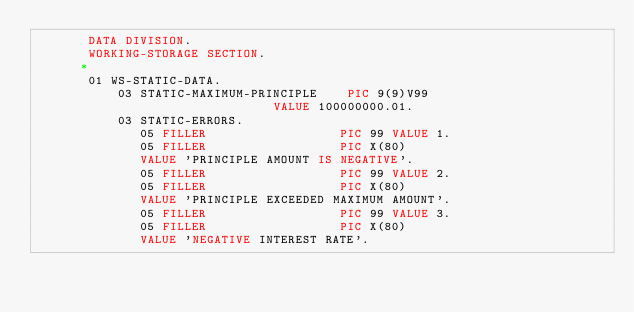<code> <loc_0><loc_0><loc_500><loc_500><_COBOL_>       DATA DIVISION.
       WORKING-STORAGE SECTION.
      *
       01 WS-STATIC-DATA.
           03 STATIC-MAXIMUM-PRINCIPLE    PIC 9(9)V99
                                VALUE 100000000.01.
           03 STATIC-ERRORS.
              05 FILLER                  PIC 99 VALUE 1.
              05 FILLER                  PIC X(80)
              VALUE 'PRINCIPLE AMOUNT IS NEGATIVE'.
              05 FILLER                  PIC 99 VALUE 2.
              05 FILLER                  PIC X(80)
              VALUE 'PRINCIPLE EXCEEDED MAXIMUM AMOUNT'.
              05 FILLER                  PIC 99 VALUE 3.
              05 FILLER                  PIC X(80)
              VALUE 'NEGATIVE INTEREST RATE'.</code> 